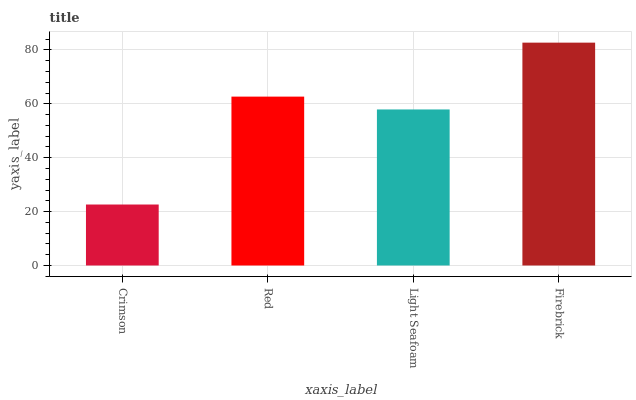Is Crimson the minimum?
Answer yes or no. Yes. Is Firebrick the maximum?
Answer yes or no. Yes. Is Red the minimum?
Answer yes or no. No. Is Red the maximum?
Answer yes or no. No. Is Red greater than Crimson?
Answer yes or no. Yes. Is Crimson less than Red?
Answer yes or no. Yes. Is Crimson greater than Red?
Answer yes or no. No. Is Red less than Crimson?
Answer yes or no. No. Is Red the high median?
Answer yes or no. Yes. Is Light Seafoam the low median?
Answer yes or no. Yes. Is Firebrick the high median?
Answer yes or no. No. Is Firebrick the low median?
Answer yes or no. No. 